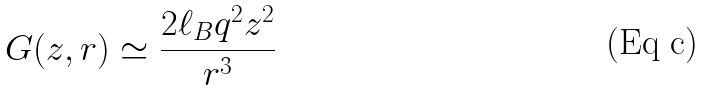Convert formula to latex. <formula><loc_0><loc_0><loc_500><loc_500>G ( z , r ) \simeq \frac { 2 \ell _ { B } q ^ { 2 } z ^ { 2 } } { r ^ { 3 } }</formula> 